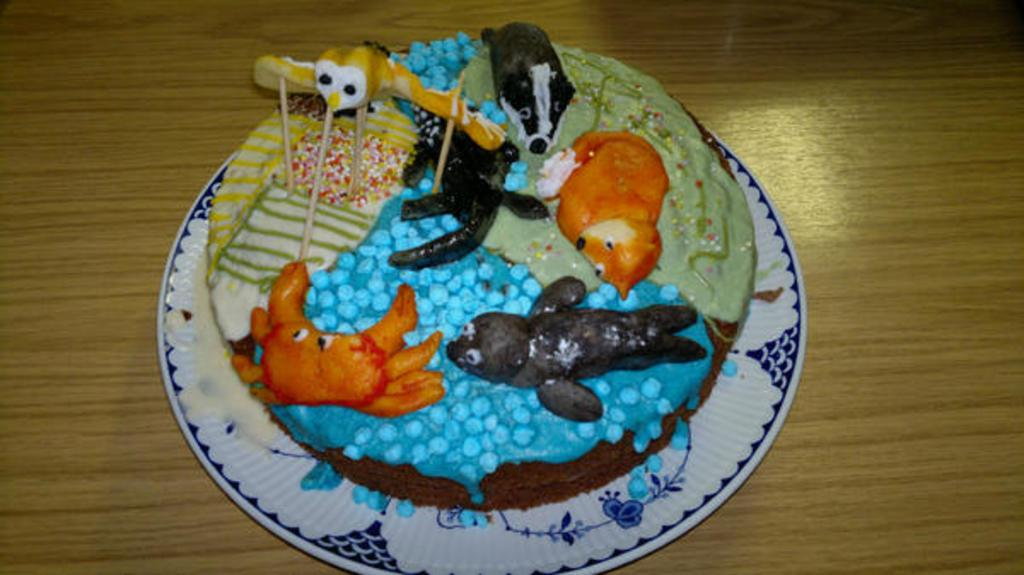What is the main subject of the image? The main subject of the image is a cake. What can be observed about the design of the cake? The cake has different pictures on it. What type of club is depicted on the cake? There is no club depicted on the cake; it has different pictures on it, but none of them are mentioned as being a club. 